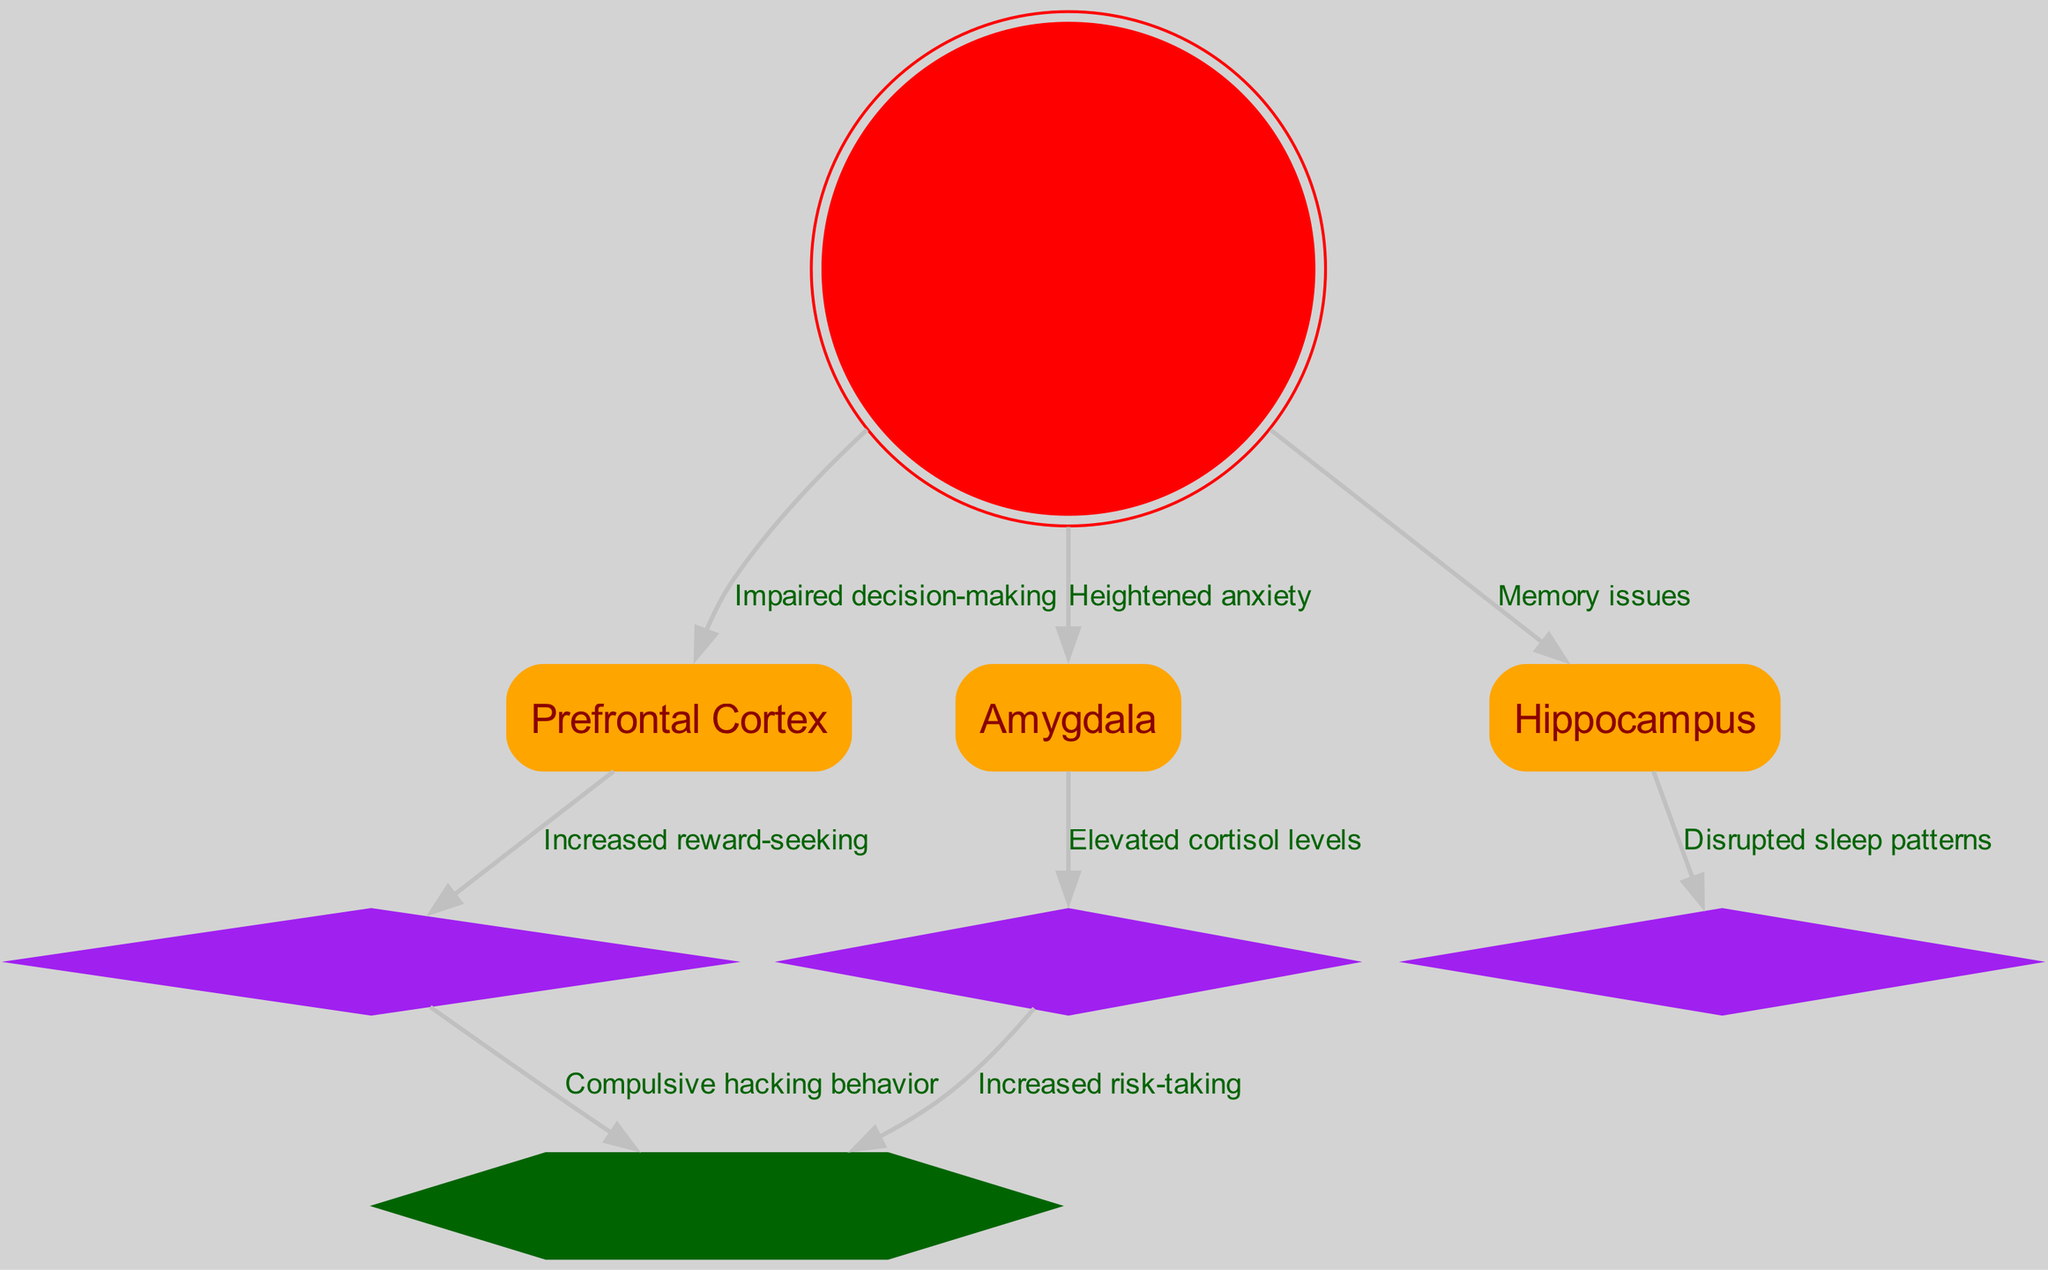What is the central node in the diagram? The central node is "Human Brain" which is represented prominently as a double circle in red, indicating its importance in the context of the diagram.
Answer: Human Brain How many nodes are present in the diagram? The diagram contains a total of 8 nodes including the main node and its sub-components. The nodes include Human Brain, Prefrontal Cortex, Amygdala, Hippocampus, Dopamine Release, Chronic Stress, Sleep Disruption, and Addiction-like Behavior.
Answer: 8 What effect does prolonged exposure to hacking have on the Prefrontal Cortex? The diagram shows a direct label from "Human Brain" to "Prefrontal Cortex" indicating "Impaired decision-making," highlighting the negative effect that prolonged hacking exposure has on this area of the brain.
Answer: Impaired decision-making What relationship exists between the Amygdala and Chronic Stress? The diagram illustrates a direct connection from "Amygdala" to "Chronic Stress," labeled with "Elevated cortisol levels," indicating that the activity in the Amygdala contributes to stress responses in the brain.
Answer: Elevated cortisol levels What is the impact of Dopamine Release on Addiction-like Behavior? According to the diagram, there is a directed edge from "Dopamine Release" to "Addiction-like Behavior" marked with "Compulsive hacking behavior." This shows that increased dopamine release can lead to behaviors characteristic of addiction.
Answer: Compulsive hacking behavior Which node is disrupted due to memory issues? The "Hippocampus" node is connected from the "Human Brain" with the label "Memory issues," indicating that this part of the brain experiences disruption as a consequence of prolonged hacking activities.
Answer: Hippocampus How does Chronic Stress increase the risk-taking behavior? In the diagram, "Chronic Stress" is linked to "Addiction-like Behavior" with the label "Increased risk-taking." This suggests that chronic stress enhances tendencies toward risky behaviors, potentially leading to addiction.
Answer: Increased risk-taking What is the consequence of hacking on sleep patterns according to the diagram? The connection from "Hippocampus" to "Sleep Disruption" indicates that the activities affecting the hippocampus are linked to disrupted sleep patterns, marking a negative impact on sleep due to prolonged hacking exposure.
Answer: Disrupted sleep patterns 